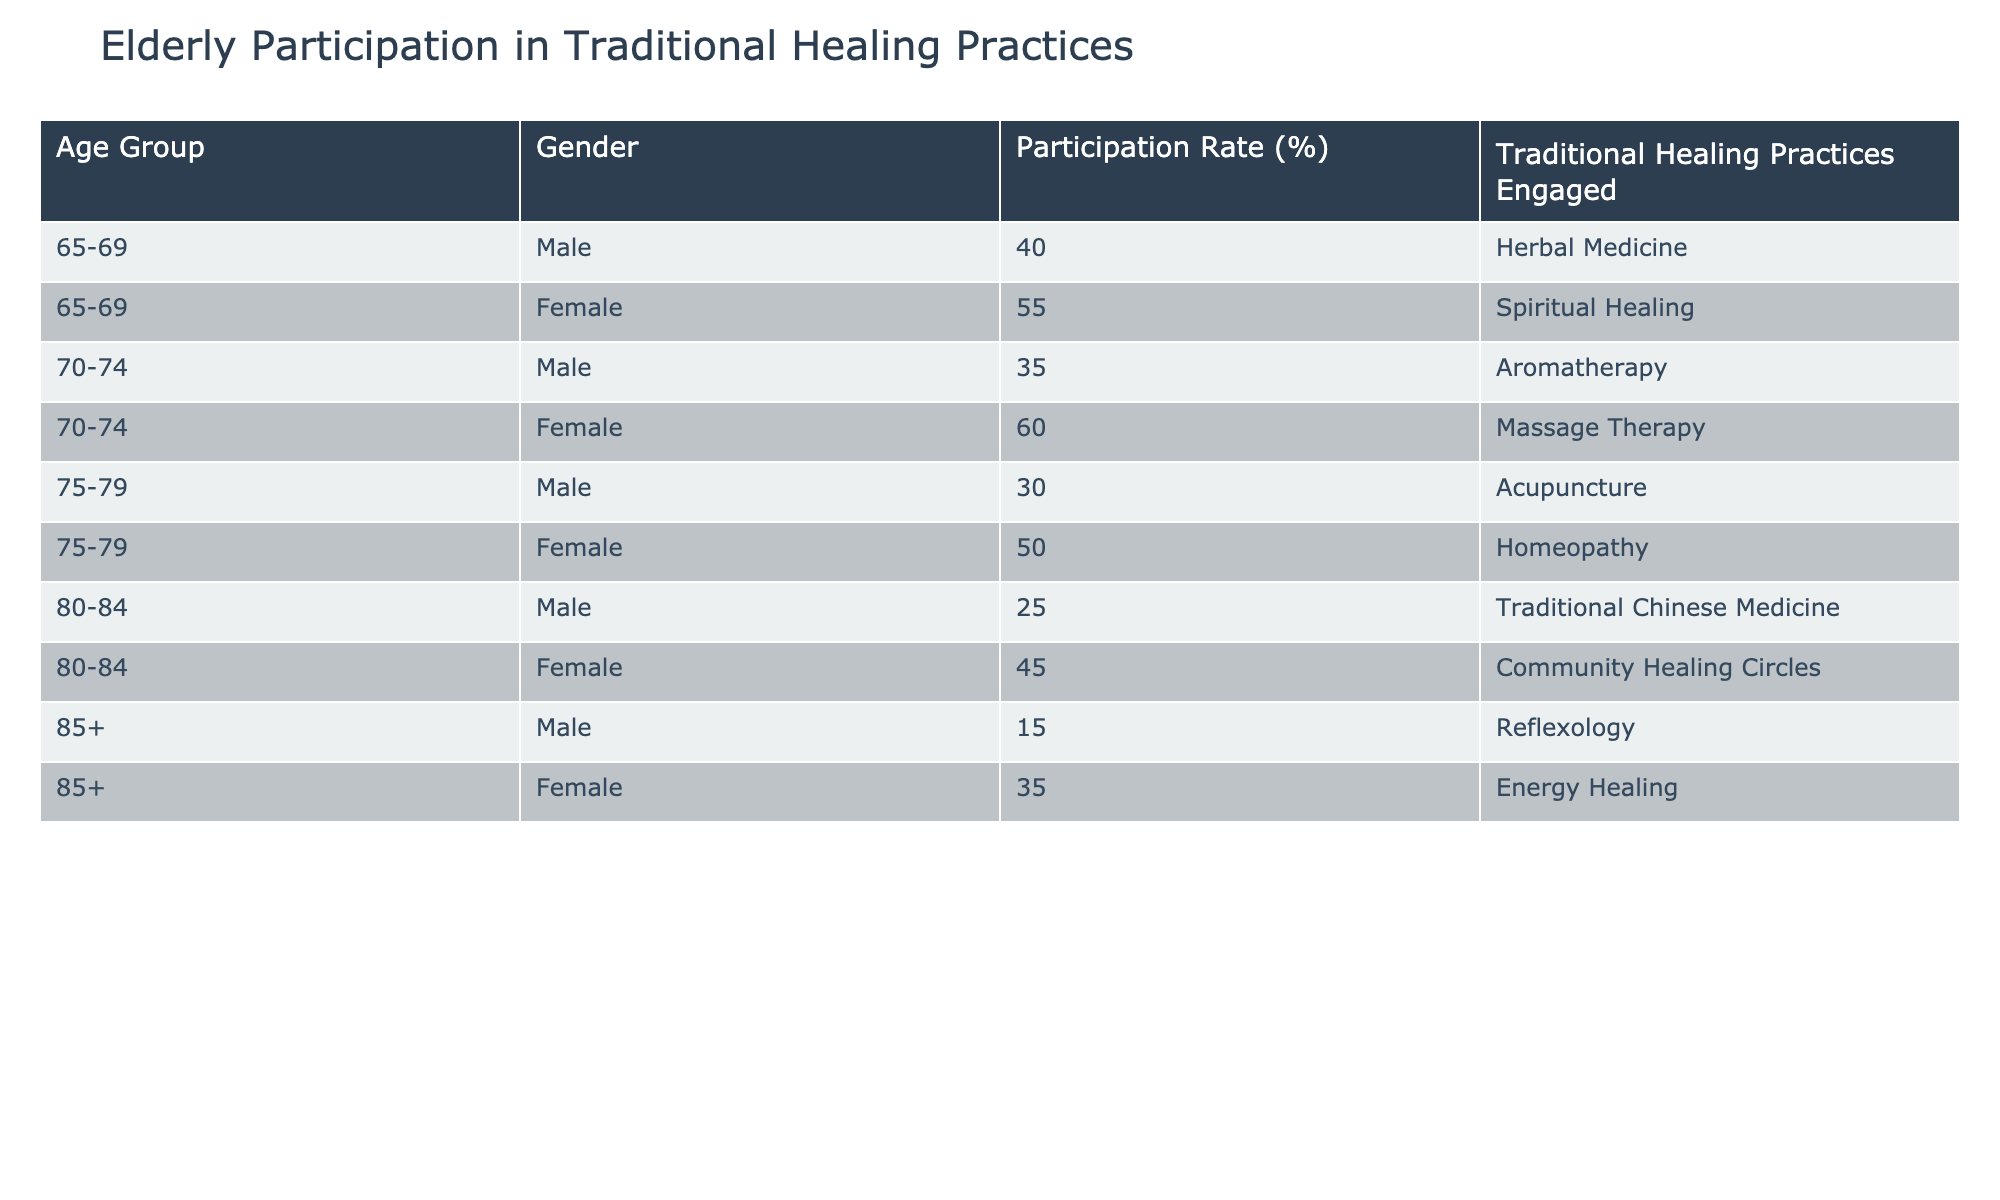What is the participation rate of elderly males in the age group 70-74? From the table, the participation rate for males aged 70-74 is listed directly under that age group, and it is 35%.
Answer: 35% What traditional healing practice do the oldest elderly females (aged 85+) engage in? Looking at the row for females aged 85 and older, the traditional healing practice they engage in is "Energy Healing" as documented in the table.
Answer: Energy Healing Which age group has the highest participation rate among females? To find this, we look for the highest value in the participation rates for females across all age groups. The highest rate is 60% for females aged 70-74, according to the table.
Answer: 60% What is the difference in participation rates between elderly males and females in the age group 75-79? For males aged 75-79, the participation rate is 30%, while for females, it is 50%. To find the difference, we subtract the males' rate from the females' rate: 50% - 30% = 20%.
Answer: 20% Are more females engaged in traditional healing practices than males overall? To determine this, we can sum the participation rates of all females and all males. The total participation rate for females is 55% + 60% + 50% + 45% + 35% = 245%. For males, it is 40% + 35% + 30% + 25% + 15% = 145%. Since 245% > 145%, the answer is yes.
Answer: Yes Which traditional healing practice has the lowest participation rate among males? The table shows participation rates for males across all age groups. The lowest rate is 15% for "Reflexology," which corresponds to males aged 85+, making it the least engaged practice.
Answer: Reflexology What is the average participation rate for elderly females across all age groups? We will sum the participation rates for females: 55% (65-69) + 60% (70-74) + 50% (75-79) + 45% (80-84) + 35% (85+) = 245% and divide by the number of female age groups, which is 5. Thus, the average participation rate is 245% / 5 = 49%.
Answer: 49% In the 80-84 age group, what is the gender participation rate discrepancy? For the 80-84 age group, males have a participation rate of 25% and females have 45%. To find the discrepancy, we subtract the male rate from the female rate: 45% - 25% = 20%.
Answer: 20% 